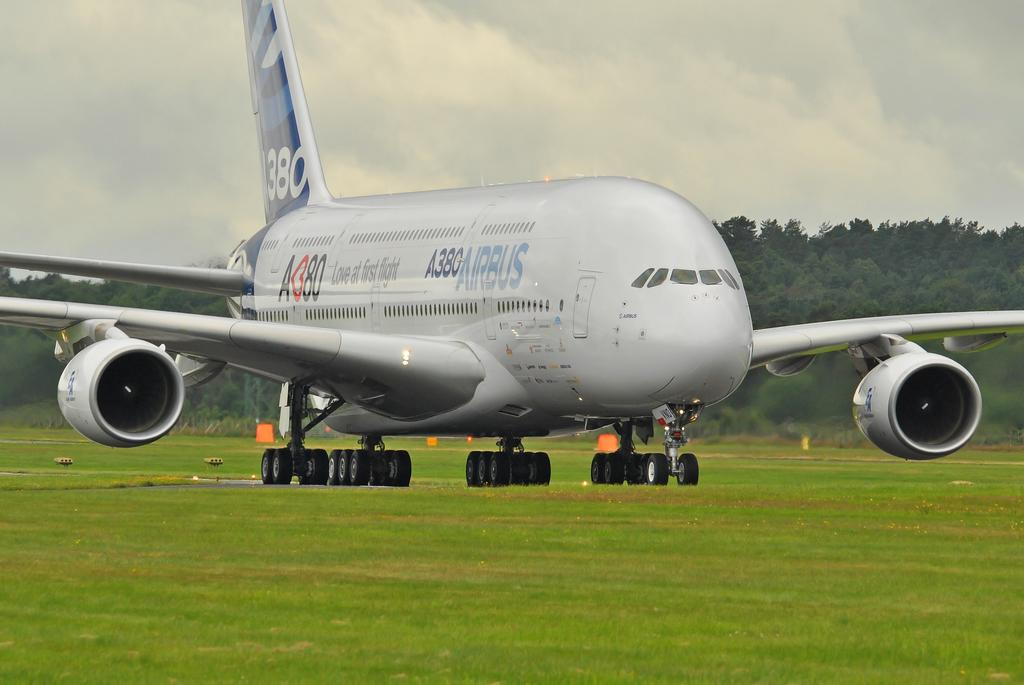<image>
Relay a brief, clear account of the picture shown. the front view of an A380 Airbus on a grassy runway 